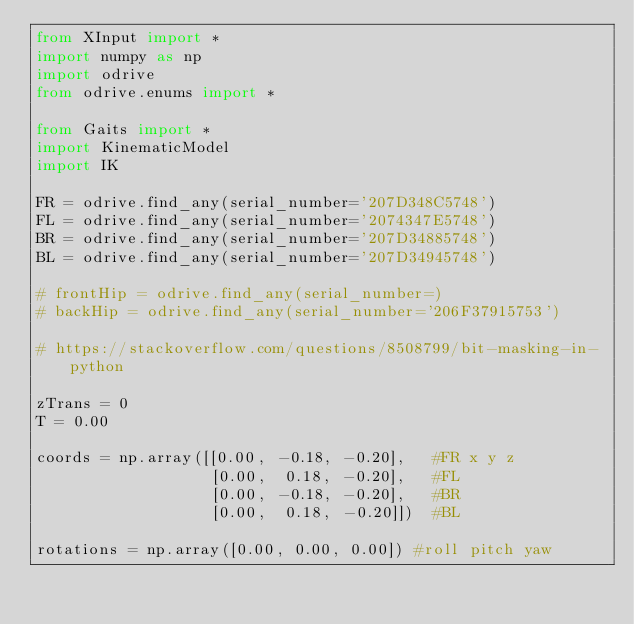Convert code to text. <code><loc_0><loc_0><loc_500><loc_500><_Python_>from XInput import *
import numpy as np
import odrive
from odrive.enums import *

from Gaits import *
import KinematicModel
import IK

FR = odrive.find_any(serial_number='207D348C5748')
FL = odrive.find_any(serial_number='2074347E5748')
BR = odrive.find_any(serial_number='207D34885748')
BL = odrive.find_any(serial_number='207D34945748')

# frontHip = odrive.find_any(serial_number=)
# backHip = odrive.find_any(serial_number='206F37915753')

# https://stackoverflow.com/questions/8508799/bit-masking-in-python

zTrans = 0
T = 0.00

coords = np.array([[0.00, -0.18, -0.20],   #FR x y z
                   [0.00,  0.18, -0.20],   #FL
                   [0.00, -0.18, -0.20],   #BR
                   [0.00,  0.18, -0.20]])  #BL

rotations = np.array([0.00, 0.00, 0.00]) #roll pitch yaw</code> 